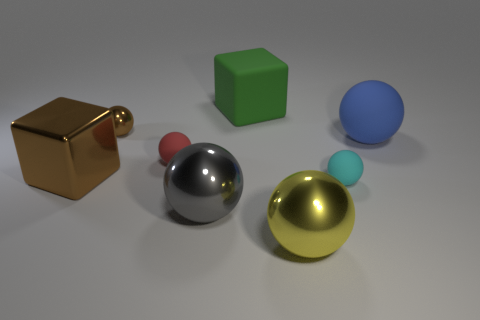Which objects in the image are reflective, and what details can you deduce from their reflections? The silver sphere and gold cube exhibit reflective surfaces. Upon closer observation, the reflections on the silver sphere reveal a light source above and the vague outline of the room's edges, suggesting a spacious environment. 